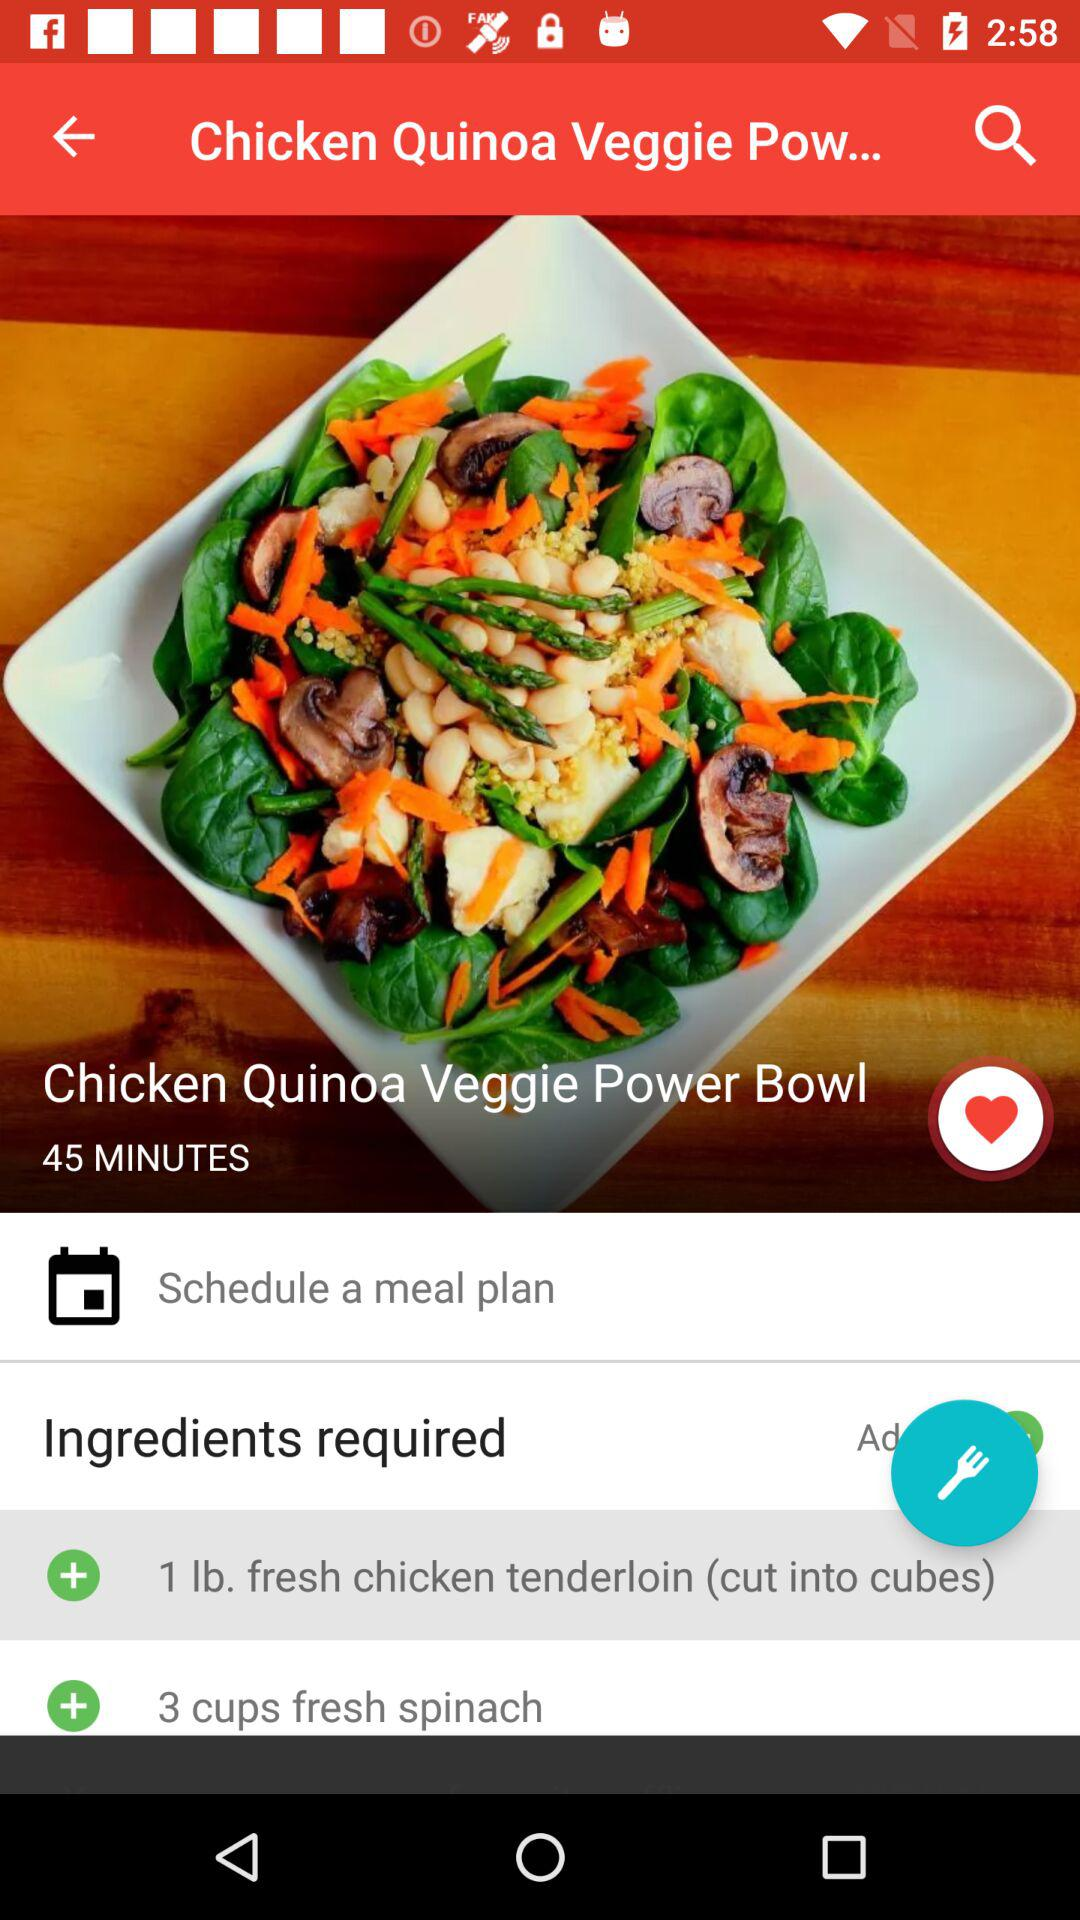How many cups of fresh spinach do I need in the recipe? You need 3 cups of fresh spinach. 